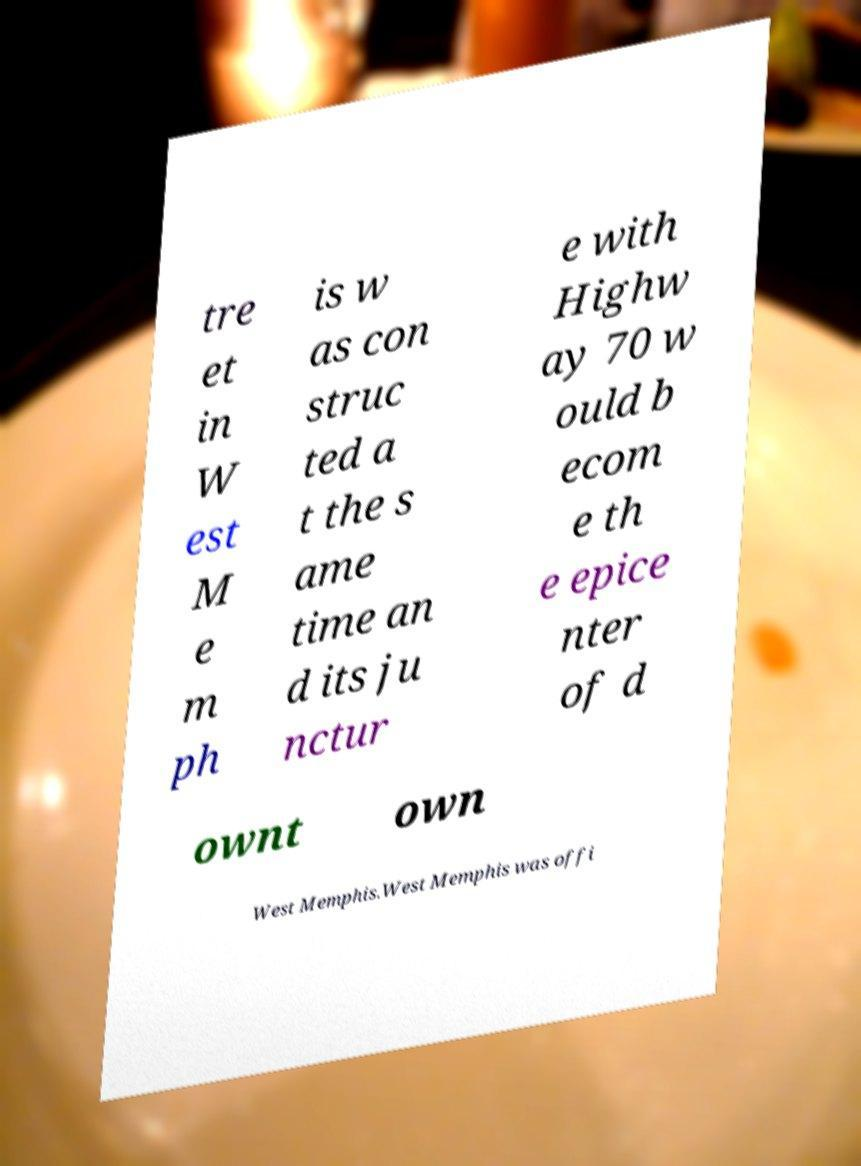Could you assist in decoding the text presented in this image and type it out clearly? tre et in W est M e m ph is w as con struc ted a t the s ame time an d its ju nctur e with Highw ay 70 w ould b ecom e th e epice nter of d ownt own West Memphis.West Memphis was offi 